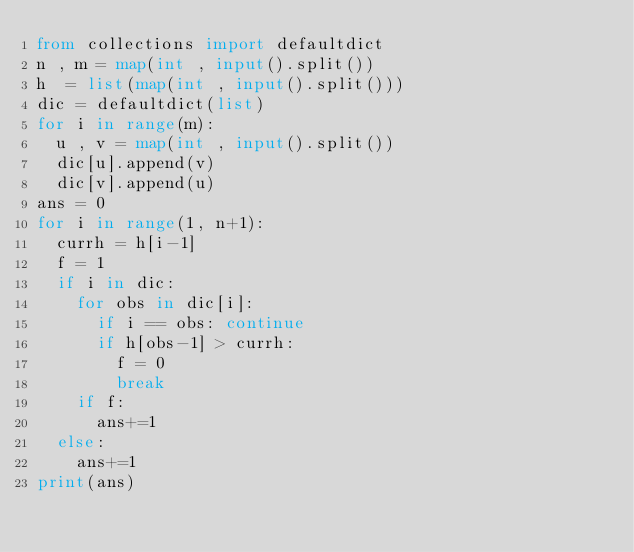Convert code to text. <code><loc_0><loc_0><loc_500><loc_500><_Python_>from collections import defaultdict
n , m = map(int , input().split())
h  = list(map(int , input().split()))
dic = defaultdict(list)
for i in range(m):
	u , v = map(int , input().split())
	dic[u].append(v)
	dic[v].append(u)
ans = 0
for i in range(1, n+1):
	currh = h[i-1]
	f = 1
	if i in dic: 
		for obs in dic[i]:
			if i == obs: continue
			if h[obs-1] > currh:
				f = 0
				break
		if f:
			ans+=1
	else:
		ans+=1
print(ans)
</code> 